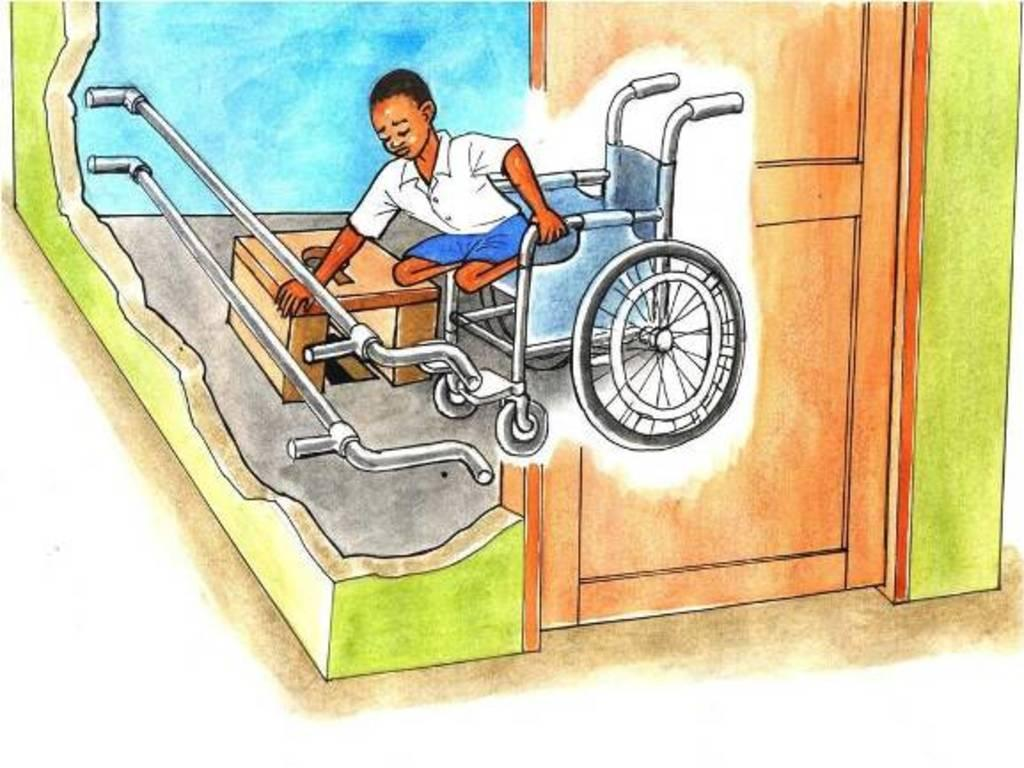What type of image is shown in the picture? There is a cartoon picture in the image. Who is the main subject of the cartoon picture? The cartoon picture depicts a boy. What is the boy doing in the image? The boy is getting down from a wheelchair in the image. What is the range of the hole in the image? There is no hole present in the image. 